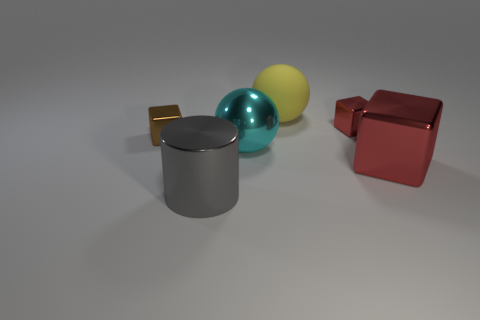The small metal thing that is on the right side of the gray metal object is what color?
Keep it short and to the point. Red. There is a large shiny cylinder; is its color the same as the shiny thing that is on the left side of the gray thing?
Your response must be concise. No. Is the number of big gray metal cylinders less than the number of large green shiny blocks?
Ensure brevity in your answer.  No. Do the small shiny object that is left of the large yellow matte thing and the metal cylinder have the same color?
Your answer should be compact. No. How many metal spheres are the same size as the rubber object?
Your response must be concise. 1. Is there a large metallic sphere of the same color as the big cube?
Provide a succinct answer. No. Is the large gray cylinder made of the same material as the large cyan thing?
Make the answer very short. Yes. How many other large red metal things are the same shape as the big red shiny object?
Give a very brief answer. 0. The small brown object that is the same material as the big cyan thing is what shape?
Make the answer very short. Cube. The big shiny object behind the red metallic object that is in front of the cyan ball is what color?
Provide a short and direct response. Cyan. 